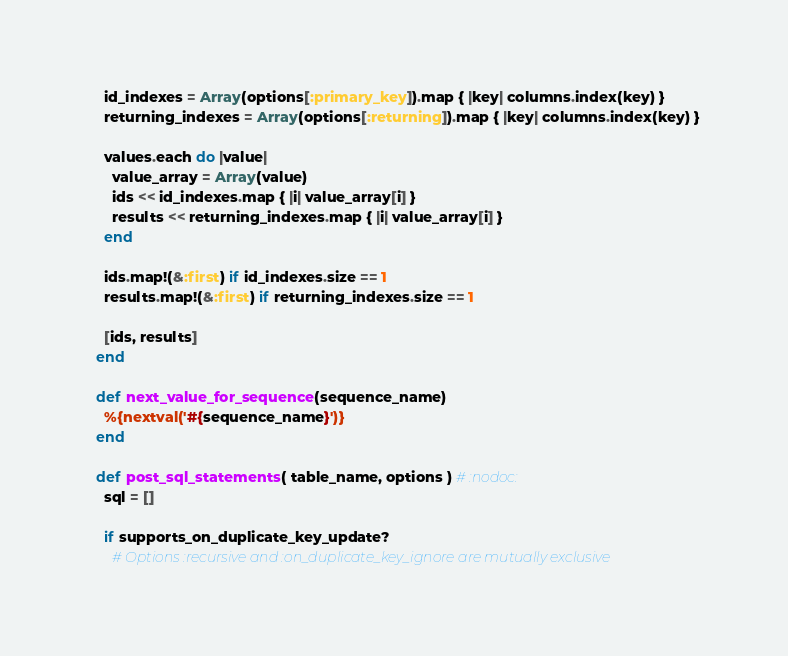Convert code to text. <code><loc_0><loc_0><loc_500><loc_500><_Ruby_>    id_indexes = Array(options[:primary_key]).map { |key| columns.index(key) }
    returning_indexes = Array(options[:returning]).map { |key| columns.index(key) }

    values.each do |value|
      value_array = Array(value)
      ids << id_indexes.map { |i| value_array[i] }
      results << returning_indexes.map { |i| value_array[i] }
    end

    ids.map!(&:first) if id_indexes.size == 1
    results.map!(&:first) if returning_indexes.size == 1

    [ids, results]
  end

  def next_value_for_sequence(sequence_name)
    %{nextval('#{sequence_name}')}
  end

  def post_sql_statements( table_name, options ) # :nodoc:
    sql = []

    if supports_on_duplicate_key_update?
      # Options :recursive and :on_duplicate_key_ignore are mutually exclusive</code> 